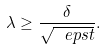Convert formula to latex. <formula><loc_0><loc_0><loc_500><loc_500>\lambda \geq \frac { \delta } { \sqrt { \ e p s t } } .</formula> 